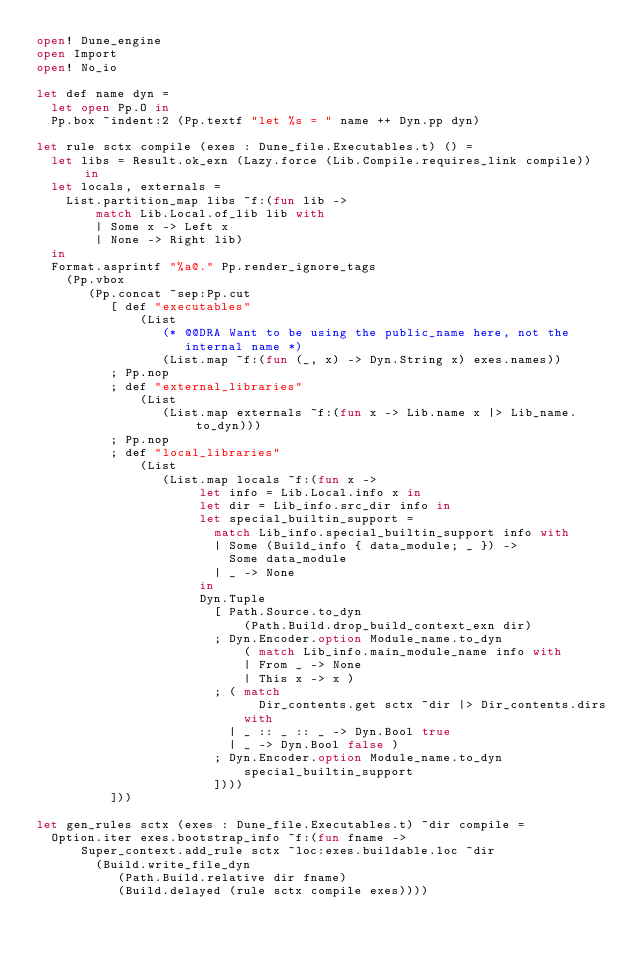Convert code to text. <code><loc_0><loc_0><loc_500><loc_500><_OCaml_>open! Dune_engine
open Import
open! No_io

let def name dyn =
  let open Pp.O in
  Pp.box ~indent:2 (Pp.textf "let %s = " name ++ Dyn.pp dyn)

let rule sctx compile (exes : Dune_file.Executables.t) () =
  let libs = Result.ok_exn (Lazy.force (Lib.Compile.requires_link compile)) in
  let locals, externals =
    List.partition_map libs ~f:(fun lib ->
        match Lib.Local.of_lib lib with
        | Some x -> Left x
        | None -> Right lib)
  in
  Format.asprintf "%a@." Pp.render_ignore_tags
    (Pp.vbox
       (Pp.concat ~sep:Pp.cut
          [ def "executables"
              (List
                 (* @@DRA Want to be using the public_name here, not the
                    internal name *)
                 (List.map ~f:(fun (_, x) -> Dyn.String x) exes.names))
          ; Pp.nop
          ; def "external_libraries"
              (List
                 (List.map externals ~f:(fun x -> Lib.name x |> Lib_name.to_dyn)))
          ; Pp.nop
          ; def "local_libraries"
              (List
                 (List.map locals ~f:(fun x ->
                      let info = Lib.Local.info x in
                      let dir = Lib_info.src_dir info in
                      let special_builtin_support =
                        match Lib_info.special_builtin_support info with
                        | Some (Build_info { data_module; _ }) ->
                          Some data_module
                        | _ -> None
                      in
                      Dyn.Tuple
                        [ Path.Source.to_dyn
                            (Path.Build.drop_build_context_exn dir)
                        ; Dyn.Encoder.option Module_name.to_dyn
                            ( match Lib_info.main_module_name info with
                            | From _ -> None
                            | This x -> x )
                        ; ( match
                              Dir_contents.get sctx ~dir |> Dir_contents.dirs
                            with
                          | _ :: _ :: _ -> Dyn.Bool true
                          | _ -> Dyn.Bool false )
                        ; Dyn.Encoder.option Module_name.to_dyn
                            special_builtin_support
                        ])))
          ]))

let gen_rules sctx (exes : Dune_file.Executables.t) ~dir compile =
  Option.iter exes.bootstrap_info ~f:(fun fname ->
      Super_context.add_rule sctx ~loc:exes.buildable.loc ~dir
        (Build.write_file_dyn
           (Path.Build.relative dir fname)
           (Build.delayed (rule sctx compile exes))))
</code> 